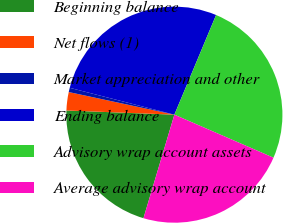Convert chart. <chart><loc_0><loc_0><loc_500><loc_500><pie_chart><fcel>Beginning balance<fcel>Net flows (1)<fcel>Market appreciation and other<fcel>Ending balance<fcel>Advisory wrap account assets<fcel>Average advisory wrap account<nl><fcel>21.0%<fcel>2.74%<fcel>0.64%<fcel>27.31%<fcel>25.21%<fcel>23.1%<nl></chart> 